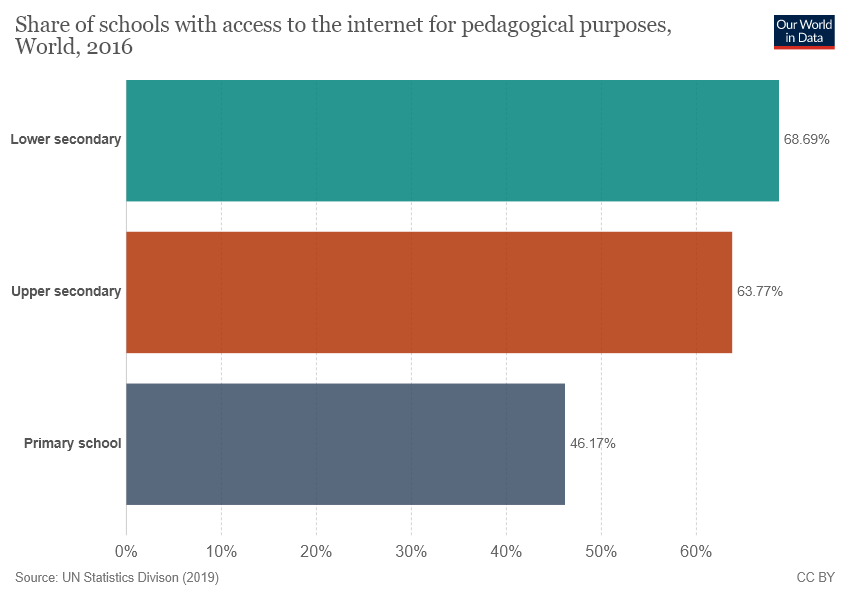Draw attention to some important aspects in this diagram. The uppermost bar has a value of 68.69. The difference between the largest and smallest bars is not equal to 1/5 of the smallest bar. 